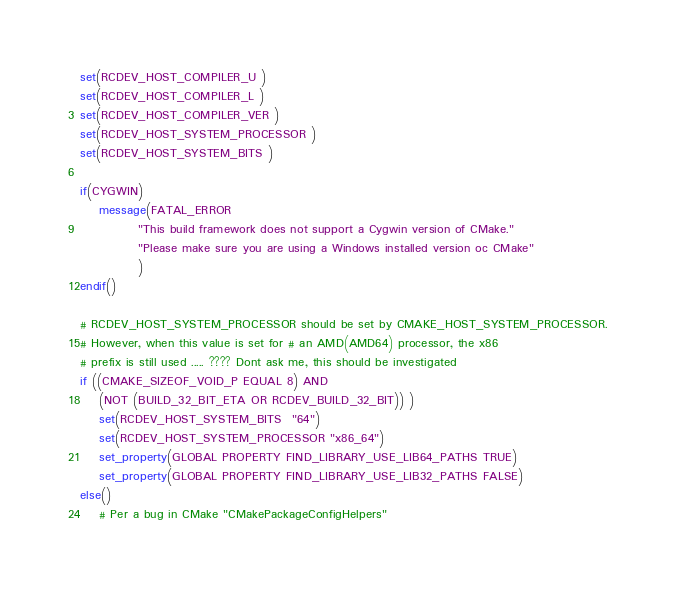Convert code to text. <code><loc_0><loc_0><loc_500><loc_500><_CMake_>set(RCDEV_HOST_COMPILER_U )
set(RCDEV_HOST_COMPILER_L )
set(RCDEV_HOST_COMPILER_VER )
set(RCDEV_HOST_SYSTEM_PROCESSOR )
set(RCDEV_HOST_SYSTEM_BITS )

if(CYGWIN)
	message(FATAL_ERROR
			"This build framework does not support a Cygwin version of CMake."
			"Please make sure you are using a Windows installed version oc CMake"
			)
endif()

# RCDEV_HOST_SYSTEM_PROCESSOR should be set by CMAKE_HOST_SYSTEM_PROCESSOR.
# However, when this value is set for # an AMD(AMD64) processor, the x86 
# prefix is still used ..... ???? Dont ask me, this should be investigated
if ((CMAKE_SIZEOF_VOID_P EQUAL 8) AND
	(NOT (BUILD_32_BIT_ETA OR RCDEV_BUILD_32_BIT)) )
	set(RCDEV_HOST_SYSTEM_BITS  "64")
	set(RCDEV_HOST_SYSTEM_PROCESSOR "x86_64")
	set_property(GLOBAL PROPERTY FIND_LIBRARY_USE_LIB64_PATHS TRUE)
	set_property(GLOBAL PROPERTY FIND_LIBRARY_USE_LIB32_PATHS FALSE)
else()
	# Per a bug in CMake "CMakePackageConfigHelpers"</code> 